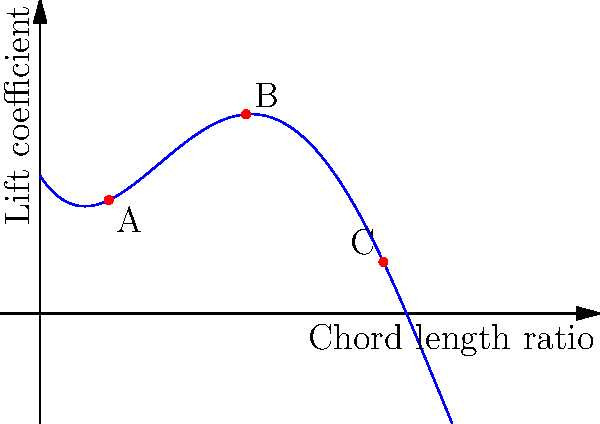The graph shows the relationship between the lift coefficient and chord length ratio for a wind turbine blade profile. Which point on the curve represents the most efficient design for maximizing power output, and why? To determine the most efficient design for maximizing power output, we need to consider the following steps:

1. Understand the graph:
   - X-axis represents the chord length ratio
   - Y-axis represents the lift coefficient
   - The curve shows how lift coefficient changes with chord length ratio

2. Analyze the curve:
   - The curve has a peak, indicating an optimal point for lift coefficient
   - Three points (A, B, and C) are marked on the curve

3. Recall the relationship between lift coefficient and power output:
   - Power output is proportional to the lift coefficient
   - Higher lift coefficient generally means higher power output

4. Examine each point:
   - Point A: Low chord length ratio, moderate lift coefficient
   - Point B: Medium chord length ratio, highest lift coefficient
   - Point C: High chord length ratio, lower lift coefficient

5. Consider the trade-offs:
   - Increasing chord length ratio initially increases lift coefficient
   - After a certain point, further increases in chord length ratio decrease lift coefficient

6. Identify the optimal point:
   - Point B has the highest lift coefficient
   - This corresponds to the peak of the curve

7. Conclude:
   - Point B represents the most efficient design for maximizing power output
   - It balances chord length ratio and lift coefficient optimally
Answer: Point B, as it has the highest lift coefficient, maximizing power output. 